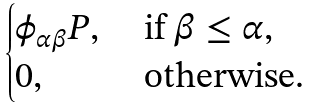Convert formula to latex. <formula><loc_0><loc_0><loc_500><loc_500>\begin{cases} \phi _ { \alpha \beta } P , & \ \text {if $\beta \leq \alpha$} , \\ 0 , & \ \text {otherwise} . \end{cases}</formula> 